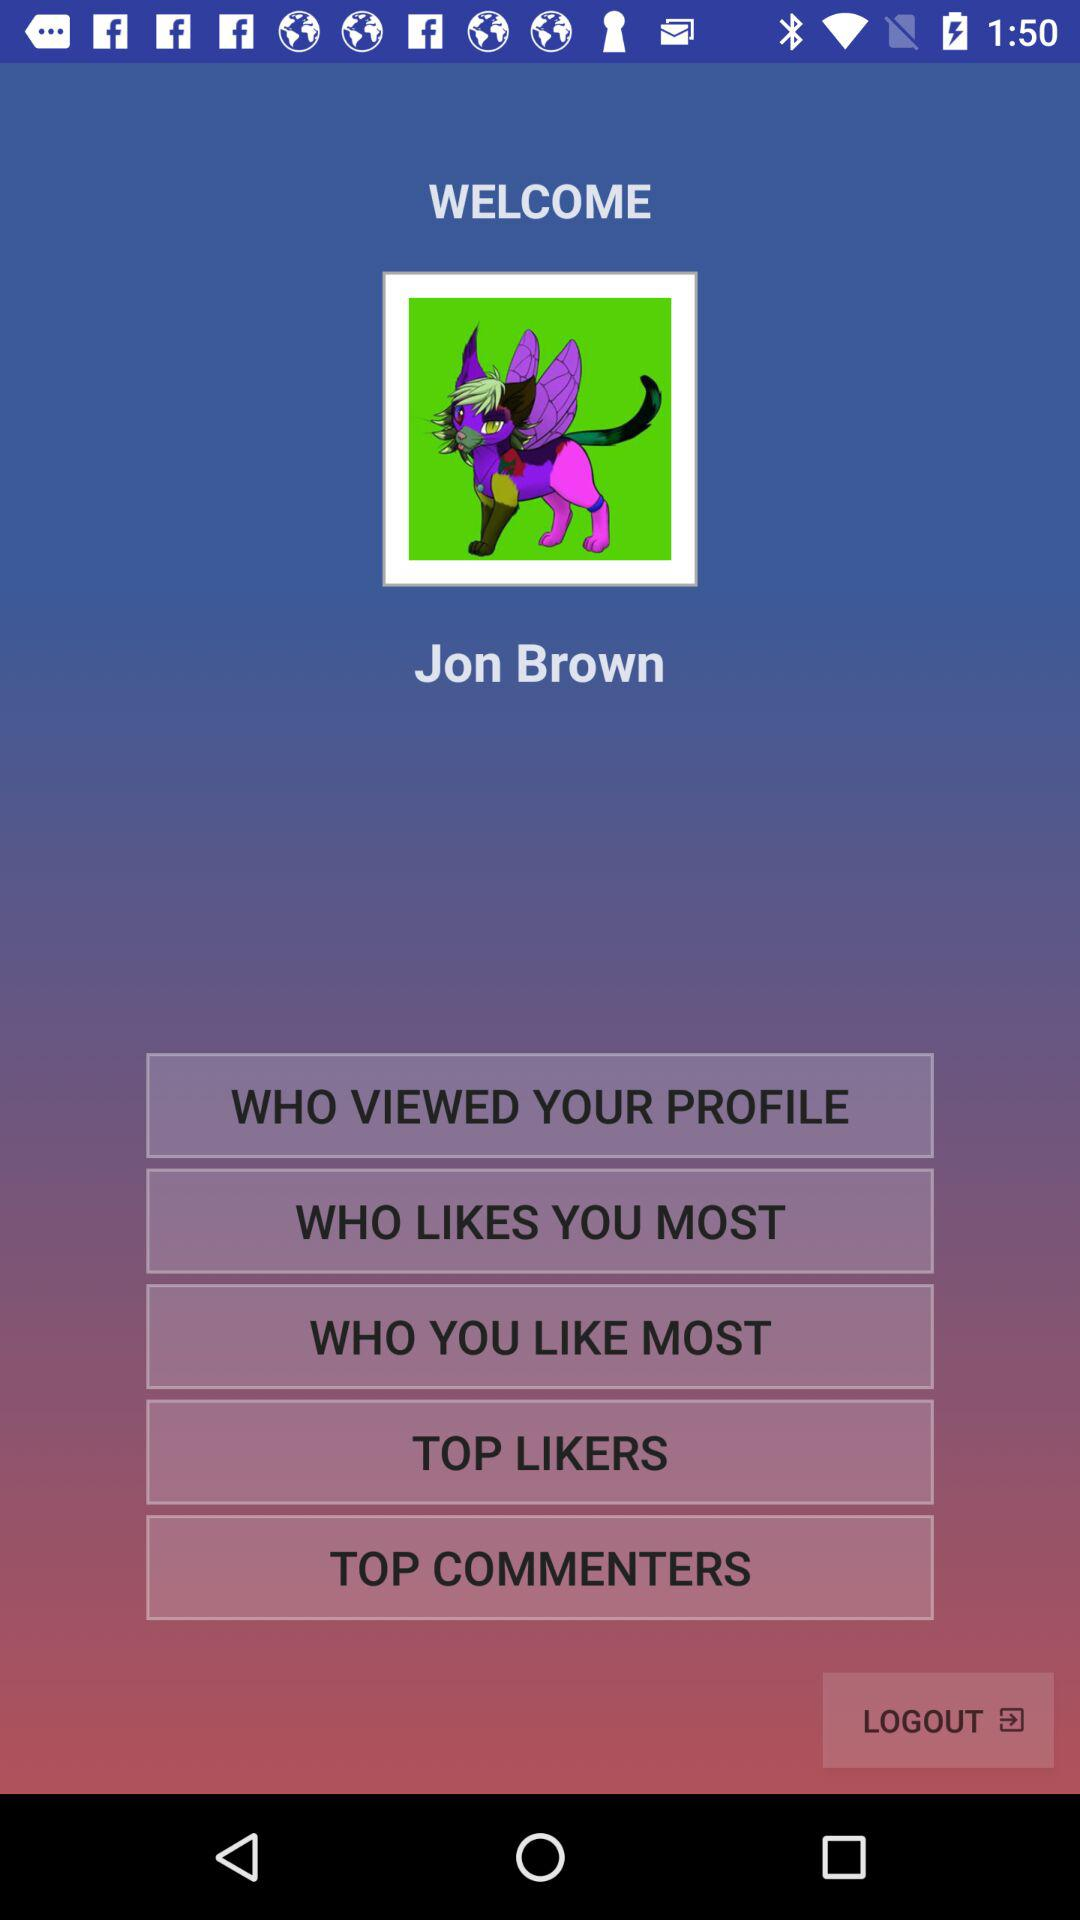What is the name of the user? The name of the user is Jon Brown. 